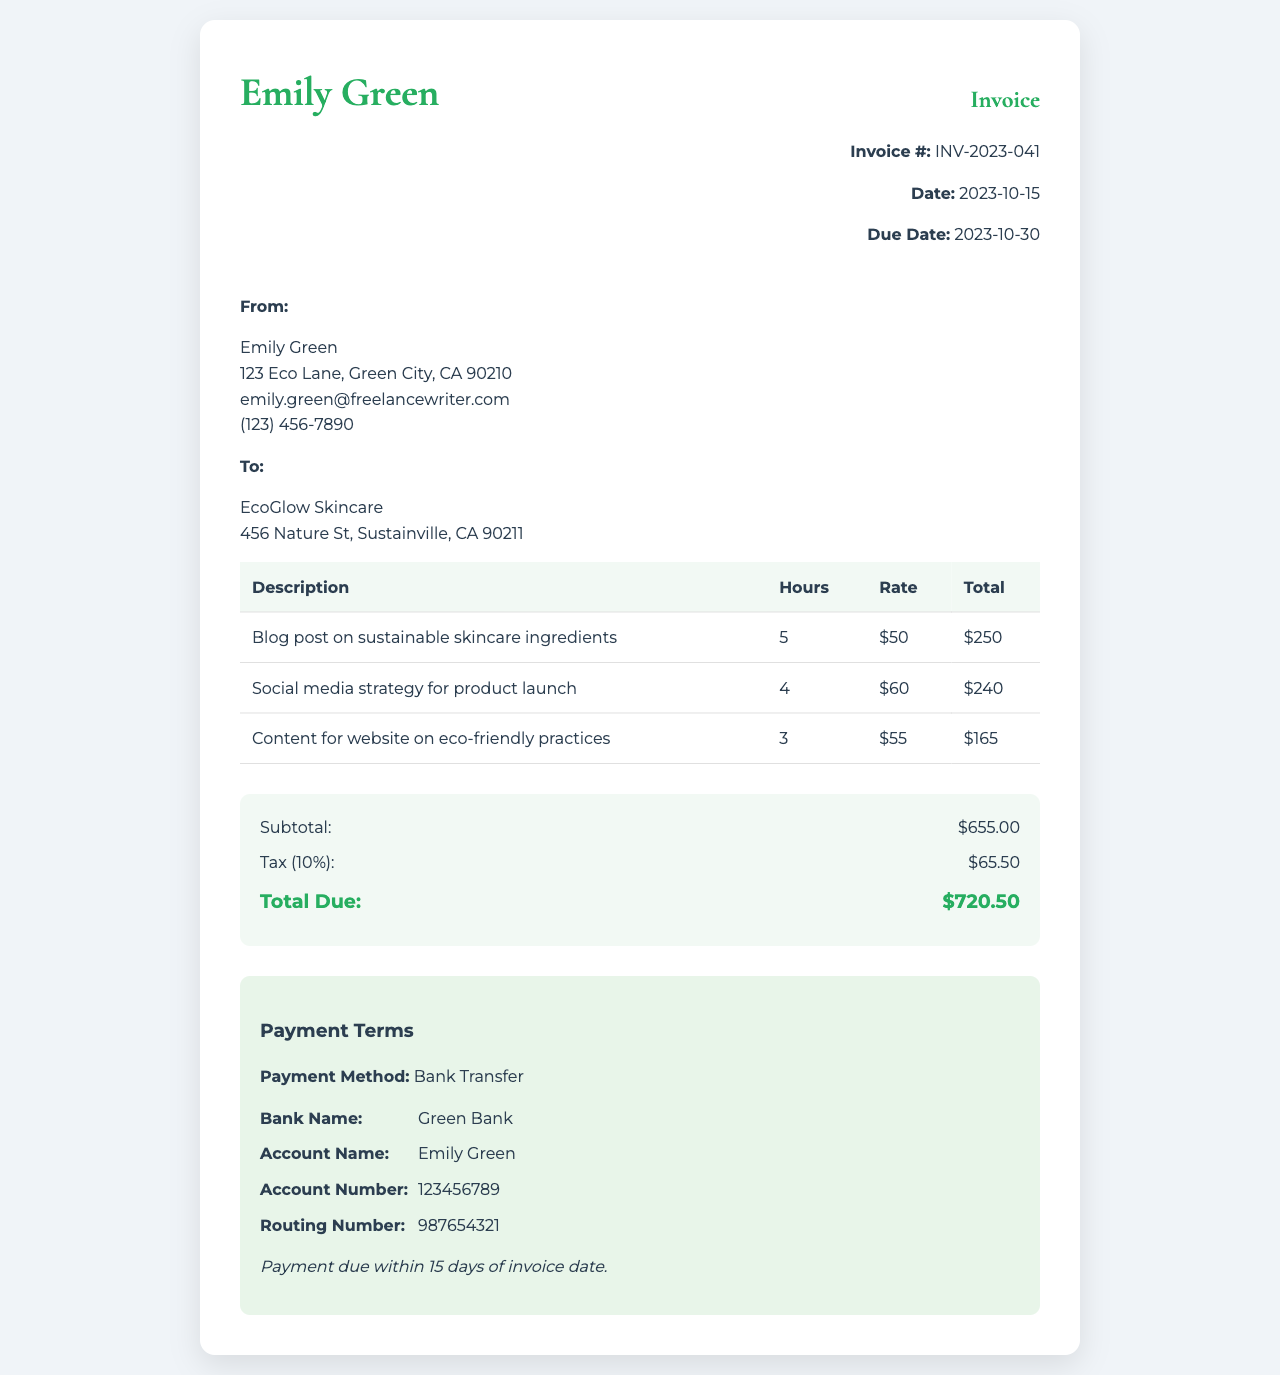what is the invoice number? The invoice number is indicated at the top of the document, which is unique to this transaction.
Answer: INV-2023-041 what is the due date? The due date for payment is mentioned clearly in the invoice.
Answer: 2023-10-30 how many hours were billed for the blog post? The number of hours for each service is listed in the table, specifically showing the blog post hours.
Answer: 5 what is the subtotal amount? The subtotal is calculated by summing the individual charges before tax, which is displayed in the summary section.
Answer: $655.00 which payment method is specified? The invoice explicitly mentions the method of payment that is accepted for this transaction.
Answer: Bank Transfer how much tax is applied? The tax amount is outlined in the summary section as a percentage of the subtotal.
Answer: $65.50 what is the total due? The total amount due is calculated by adding the subtotal and the tax, listed in the summary section.
Answer: $720.50 who is the recipient of the invoice? The invoice includes the name and address of the recipient, indicating to whom the payment is to be made.
Answer: EcoGlow Skincare what service had the highest hourly rate? The hourly rates for the services are shown in the table, allowing for comparison.
Answer: Social media strategy for product launch 